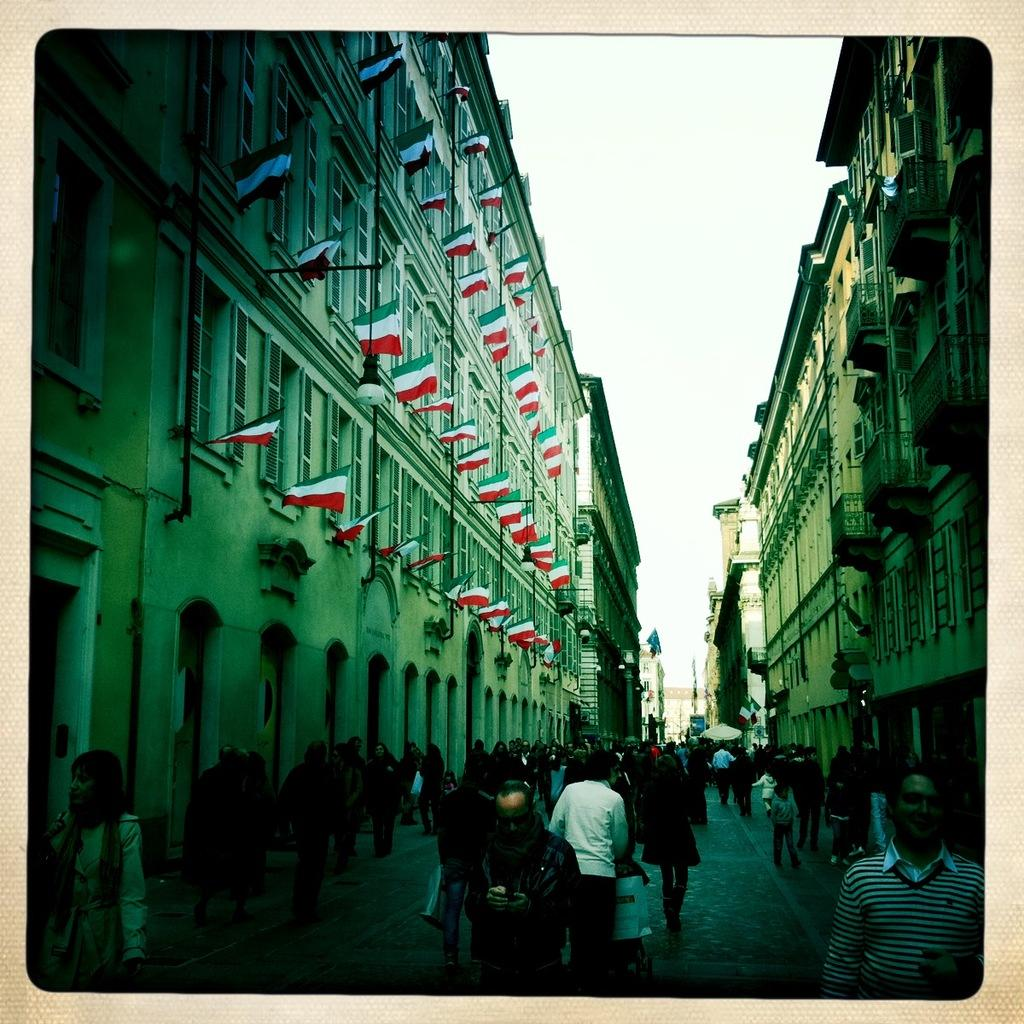What type of border surrounds the image? The image has borders. What structures can be seen in the image? There are buildings in the image. What symbols are present in the image? There are flags in the image. What objects are supporting the flags? There are poles in the image. What are the people in the image doing? There are people walking in the image. What is at the bottom of the image? There is a road at the bottom of the image. What is visible at the top of the image? There is sky visible at the top of the image. How many toothbrushes are visible in the image? There are no toothbrushes present in the image. What type of chairs can be seen in the image? There are no chairs present in the image. 